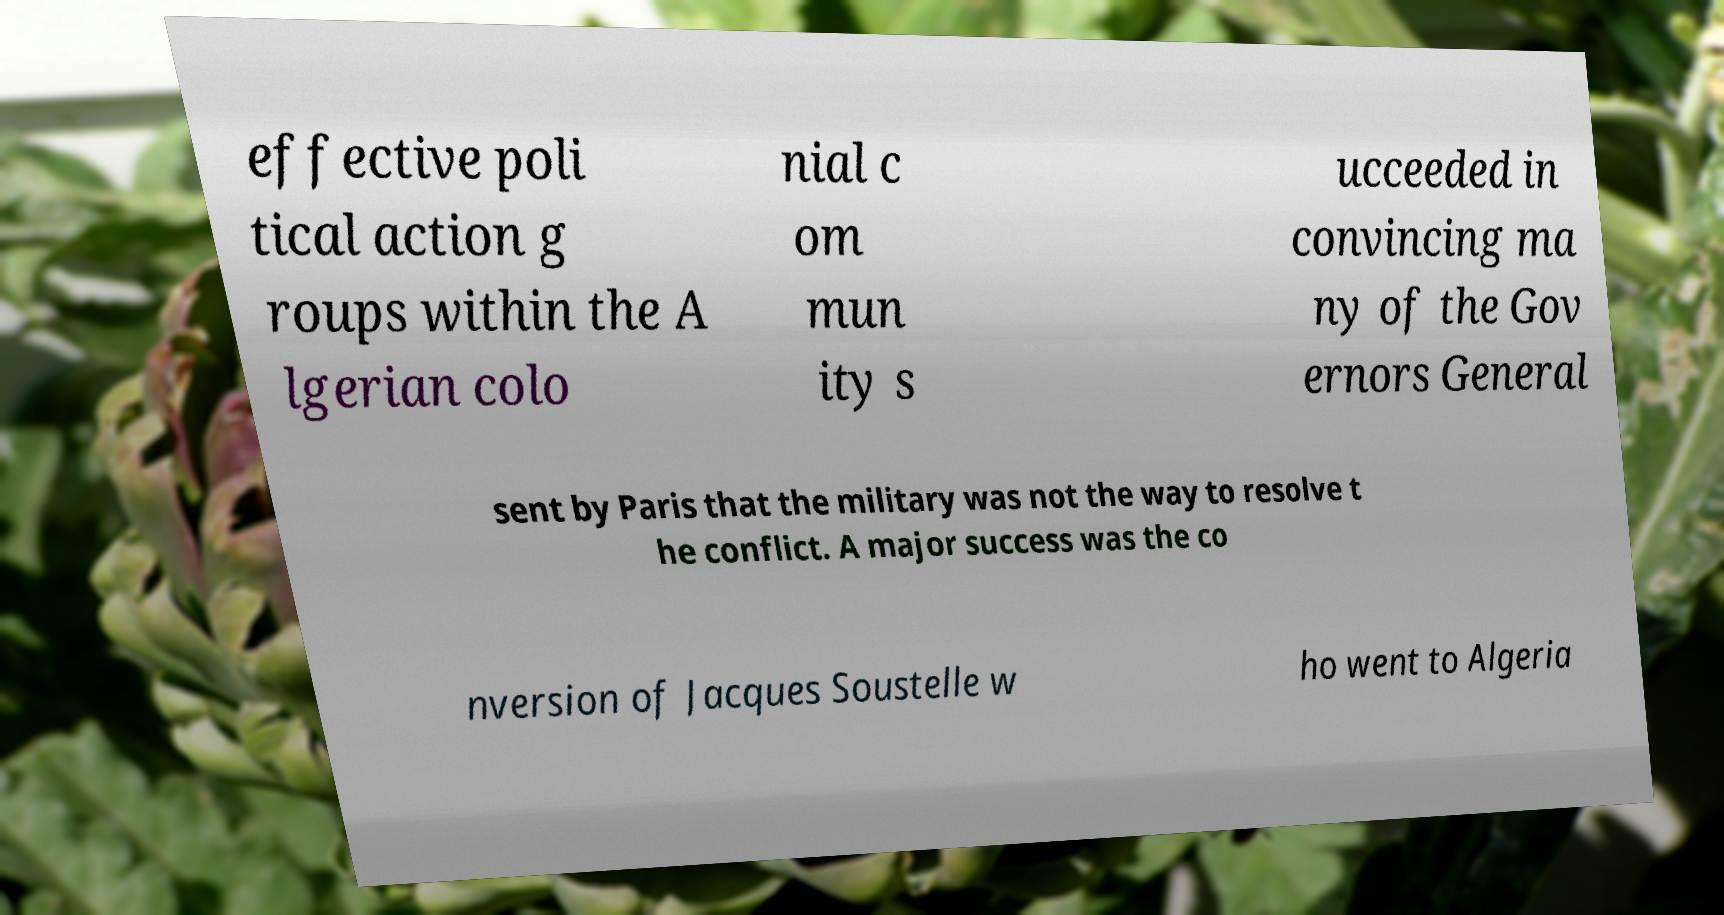There's text embedded in this image that I need extracted. Can you transcribe it verbatim? effective poli tical action g roups within the A lgerian colo nial c om mun ity s ucceeded in convincing ma ny of the Gov ernors General sent by Paris that the military was not the way to resolve t he conflict. A major success was the co nversion of Jacques Soustelle w ho went to Algeria 